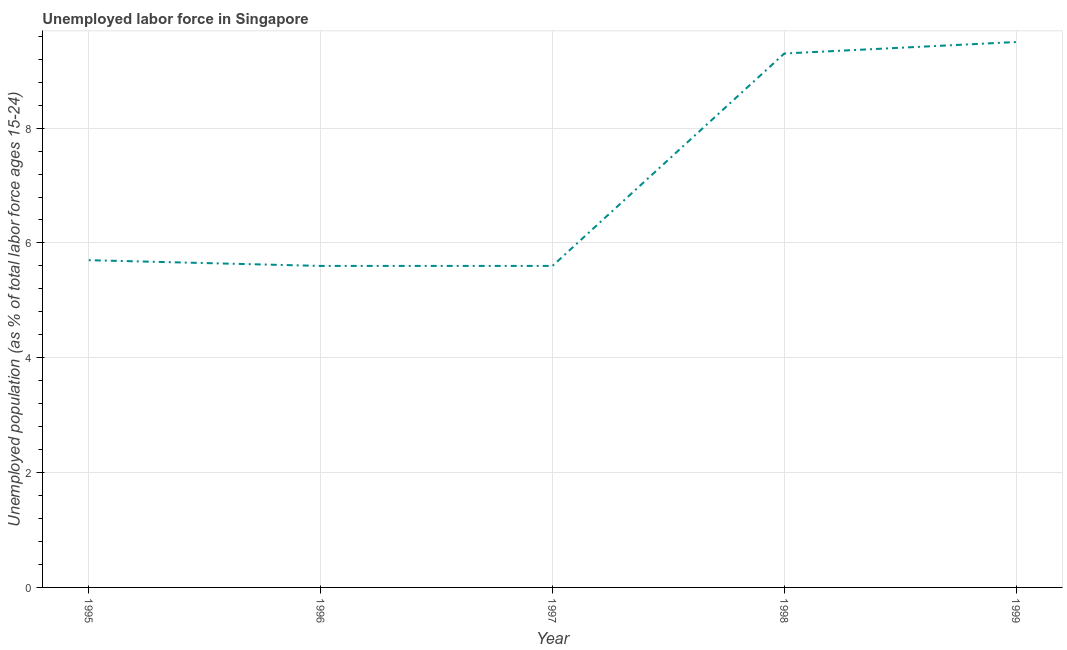What is the total unemployed youth population in 1997?
Keep it short and to the point. 5.6. Across all years, what is the maximum total unemployed youth population?
Keep it short and to the point. 9.5. Across all years, what is the minimum total unemployed youth population?
Provide a short and direct response. 5.6. In which year was the total unemployed youth population minimum?
Make the answer very short. 1996. What is the sum of the total unemployed youth population?
Make the answer very short. 35.7. What is the difference between the total unemployed youth population in 1995 and 1998?
Ensure brevity in your answer.  -3.6. What is the average total unemployed youth population per year?
Keep it short and to the point. 7.14. What is the median total unemployed youth population?
Provide a succinct answer. 5.7. What is the ratio of the total unemployed youth population in 1996 to that in 1997?
Provide a short and direct response. 1. Is the difference between the total unemployed youth population in 1996 and 1999 greater than the difference between any two years?
Provide a succinct answer. Yes. What is the difference between the highest and the second highest total unemployed youth population?
Make the answer very short. 0.2. Is the sum of the total unemployed youth population in 1997 and 1998 greater than the maximum total unemployed youth population across all years?
Provide a succinct answer. Yes. What is the difference between the highest and the lowest total unemployed youth population?
Offer a terse response. 3.9. In how many years, is the total unemployed youth population greater than the average total unemployed youth population taken over all years?
Provide a succinct answer. 2. Does the total unemployed youth population monotonically increase over the years?
Your response must be concise. No. How many lines are there?
Your answer should be compact. 1. Are the values on the major ticks of Y-axis written in scientific E-notation?
Offer a very short reply. No. What is the title of the graph?
Your answer should be very brief. Unemployed labor force in Singapore. What is the label or title of the Y-axis?
Offer a terse response. Unemployed population (as % of total labor force ages 15-24). What is the Unemployed population (as % of total labor force ages 15-24) in 1995?
Make the answer very short. 5.7. What is the Unemployed population (as % of total labor force ages 15-24) of 1996?
Your answer should be compact. 5.6. What is the Unemployed population (as % of total labor force ages 15-24) in 1997?
Your response must be concise. 5.6. What is the Unemployed population (as % of total labor force ages 15-24) of 1998?
Your answer should be very brief. 9.3. What is the difference between the Unemployed population (as % of total labor force ages 15-24) in 1995 and 1997?
Give a very brief answer. 0.1. What is the difference between the Unemployed population (as % of total labor force ages 15-24) in 1995 and 1998?
Make the answer very short. -3.6. What is the difference between the Unemployed population (as % of total labor force ages 15-24) in 1995 and 1999?
Make the answer very short. -3.8. What is the difference between the Unemployed population (as % of total labor force ages 15-24) in 1996 and 1997?
Offer a terse response. 0. What is the difference between the Unemployed population (as % of total labor force ages 15-24) in 1996 and 1998?
Your response must be concise. -3.7. What is the difference between the Unemployed population (as % of total labor force ages 15-24) in 1996 and 1999?
Offer a terse response. -3.9. What is the difference between the Unemployed population (as % of total labor force ages 15-24) in 1997 and 1999?
Your answer should be compact. -3.9. What is the ratio of the Unemployed population (as % of total labor force ages 15-24) in 1995 to that in 1997?
Give a very brief answer. 1.02. What is the ratio of the Unemployed population (as % of total labor force ages 15-24) in 1995 to that in 1998?
Your response must be concise. 0.61. What is the ratio of the Unemployed population (as % of total labor force ages 15-24) in 1995 to that in 1999?
Offer a very short reply. 0.6. What is the ratio of the Unemployed population (as % of total labor force ages 15-24) in 1996 to that in 1998?
Offer a very short reply. 0.6. What is the ratio of the Unemployed population (as % of total labor force ages 15-24) in 1996 to that in 1999?
Offer a terse response. 0.59. What is the ratio of the Unemployed population (as % of total labor force ages 15-24) in 1997 to that in 1998?
Offer a terse response. 0.6. What is the ratio of the Unemployed population (as % of total labor force ages 15-24) in 1997 to that in 1999?
Your answer should be compact. 0.59. 